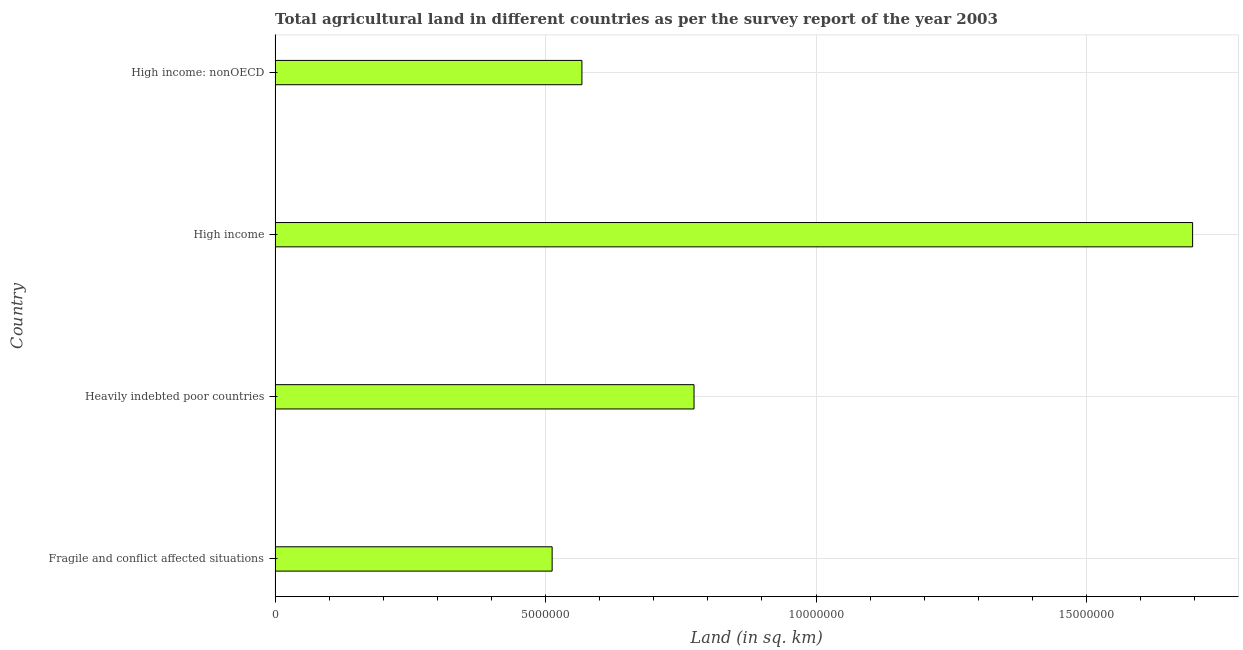Does the graph contain any zero values?
Offer a very short reply. No. Does the graph contain grids?
Ensure brevity in your answer.  Yes. What is the title of the graph?
Offer a terse response. Total agricultural land in different countries as per the survey report of the year 2003. What is the label or title of the X-axis?
Offer a very short reply. Land (in sq. km). What is the agricultural land in Heavily indebted poor countries?
Give a very brief answer. 7.74e+06. Across all countries, what is the maximum agricultural land?
Your answer should be very brief. 1.70e+07. Across all countries, what is the minimum agricultural land?
Make the answer very short. 5.12e+06. In which country was the agricultural land minimum?
Your answer should be compact. Fragile and conflict affected situations. What is the sum of the agricultural land?
Give a very brief answer. 3.55e+07. What is the difference between the agricultural land in Heavily indebted poor countries and High income?
Ensure brevity in your answer.  -9.22e+06. What is the average agricultural land per country?
Your response must be concise. 8.88e+06. What is the median agricultural land?
Give a very brief answer. 6.71e+06. What is the ratio of the agricultural land in Fragile and conflict affected situations to that in Heavily indebted poor countries?
Offer a very short reply. 0.66. Is the agricultural land in Fragile and conflict affected situations less than that in High income?
Provide a short and direct response. Yes. What is the difference between the highest and the second highest agricultural land?
Provide a short and direct response. 9.22e+06. What is the difference between the highest and the lowest agricultural land?
Make the answer very short. 1.18e+07. In how many countries, is the agricultural land greater than the average agricultural land taken over all countries?
Ensure brevity in your answer.  1. How many bars are there?
Offer a terse response. 4. How many countries are there in the graph?
Provide a short and direct response. 4. What is the difference between two consecutive major ticks on the X-axis?
Your answer should be compact. 5.00e+06. Are the values on the major ticks of X-axis written in scientific E-notation?
Offer a terse response. No. What is the Land (in sq. km) of Fragile and conflict affected situations?
Provide a short and direct response. 5.12e+06. What is the Land (in sq. km) of Heavily indebted poor countries?
Ensure brevity in your answer.  7.74e+06. What is the Land (in sq. km) of High income?
Provide a succinct answer. 1.70e+07. What is the Land (in sq. km) of High income: nonOECD?
Provide a short and direct response. 5.67e+06. What is the difference between the Land (in sq. km) in Fragile and conflict affected situations and Heavily indebted poor countries?
Offer a terse response. -2.62e+06. What is the difference between the Land (in sq. km) in Fragile and conflict affected situations and High income?
Keep it short and to the point. -1.18e+07. What is the difference between the Land (in sq. km) in Fragile and conflict affected situations and High income: nonOECD?
Your answer should be very brief. -5.50e+05. What is the difference between the Land (in sq. km) in Heavily indebted poor countries and High income?
Your answer should be compact. -9.22e+06. What is the difference between the Land (in sq. km) in Heavily indebted poor countries and High income: nonOECD?
Offer a very short reply. 2.07e+06. What is the difference between the Land (in sq. km) in High income and High income: nonOECD?
Provide a short and direct response. 1.13e+07. What is the ratio of the Land (in sq. km) in Fragile and conflict affected situations to that in Heavily indebted poor countries?
Your response must be concise. 0.66. What is the ratio of the Land (in sq. km) in Fragile and conflict affected situations to that in High income?
Your answer should be compact. 0.3. What is the ratio of the Land (in sq. km) in Fragile and conflict affected situations to that in High income: nonOECD?
Provide a succinct answer. 0.9. What is the ratio of the Land (in sq. km) in Heavily indebted poor countries to that in High income?
Offer a very short reply. 0.46. What is the ratio of the Land (in sq. km) in Heavily indebted poor countries to that in High income: nonOECD?
Offer a terse response. 1.36. What is the ratio of the Land (in sq. km) in High income to that in High income: nonOECD?
Your response must be concise. 2.99. 